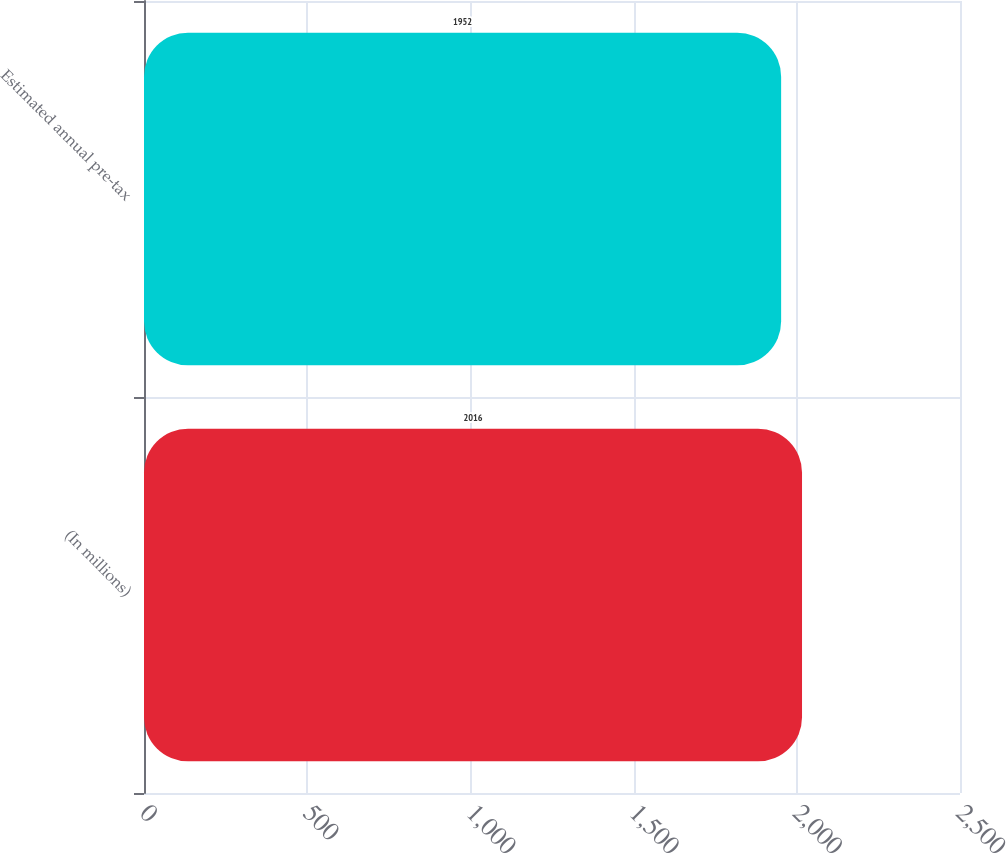Convert chart. <chart><loc_0><loc_0><loc_500><loc_500><bar_chart><fcel>(In millions)<fcel>Estimated annual pre-tax<nl><fcel>2016<fcel>1952<nl></chart> 